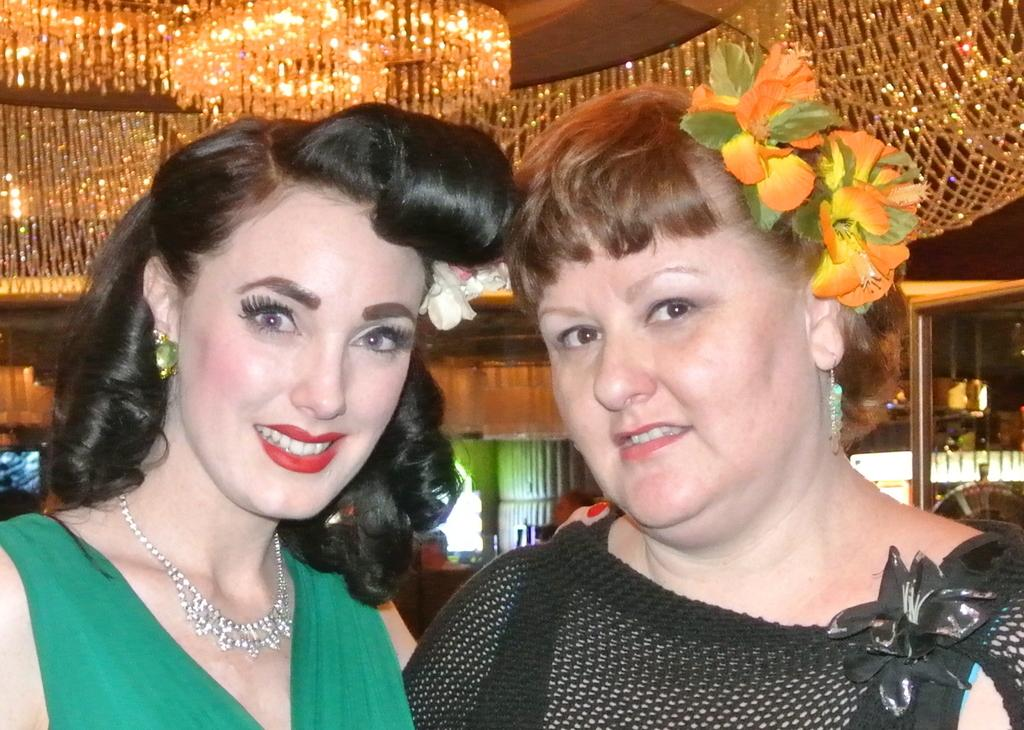How many people are in the image? There are two people in the image. What colors are the dresses worn by the people in the image? The person on the right is wearing a black dress, and the person on the left is wearing a green dress. What can be seen in the background of the image? There are lights visible in the background of the image. How many horses are present in the image? There are no horses present in the image. What type of brake system is used on the green dress in the image? The green dress in the image is not a vehicle and does not have a brake system. 